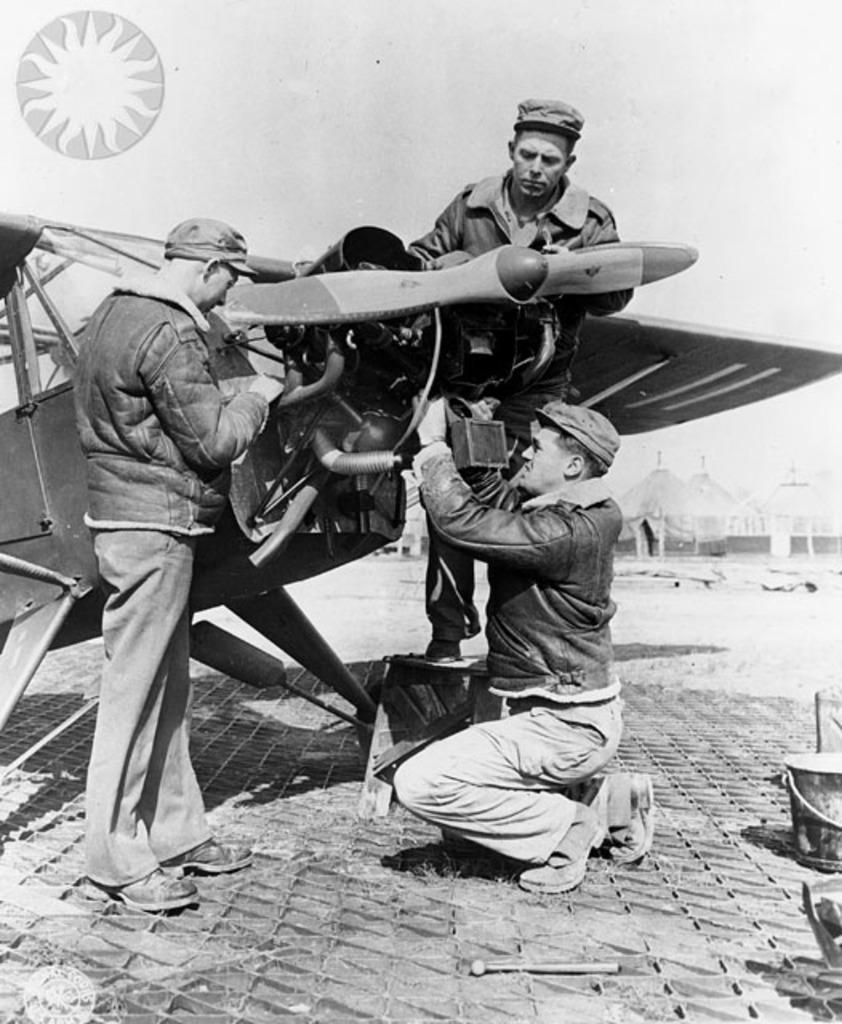What is the color scheme of the image? The image is black and white. What are the men in the image doing? The men are standing and sitting, and they are interacting with a machine. What can be seen in the background of the image? There are buildings and the sky visible in the background of the image. How many friends are sitting on the leg of the machine in the image? There are no friends or legs of a machine present in the image; it features men interacting with a machine in a black and white setting. 